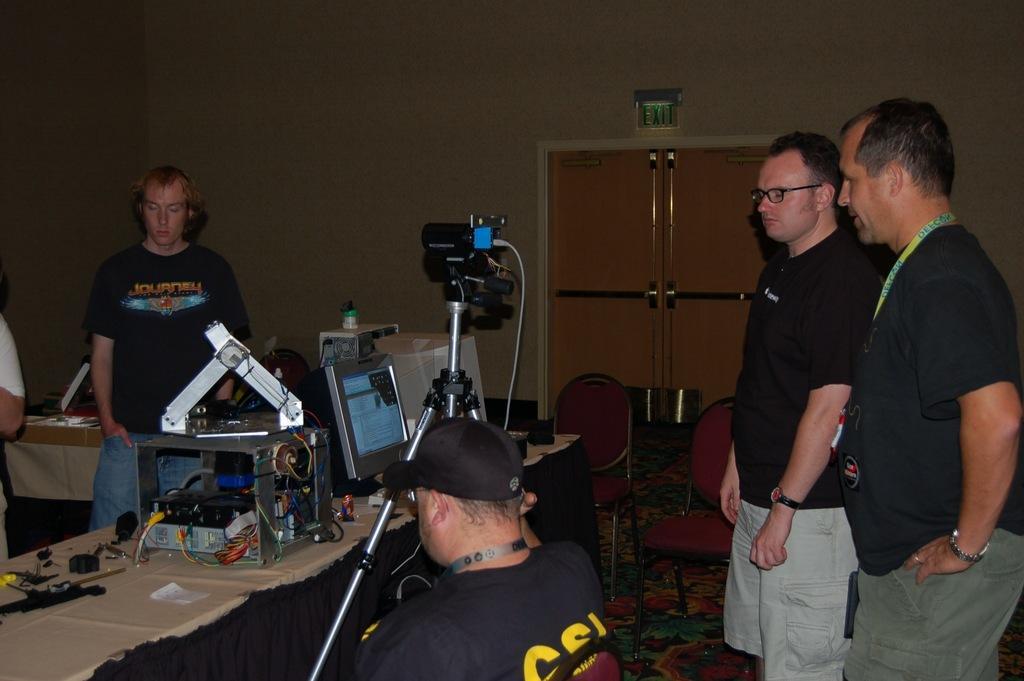Please provide a concise description of this image. On the right side of the image we can see persons standing on the floor. In the center of the image we can see person sitting at the table. On the table we can see some components of the computer, monitor and some objects. In the background we can see door and wall. On the left side of the image we can see persons. 